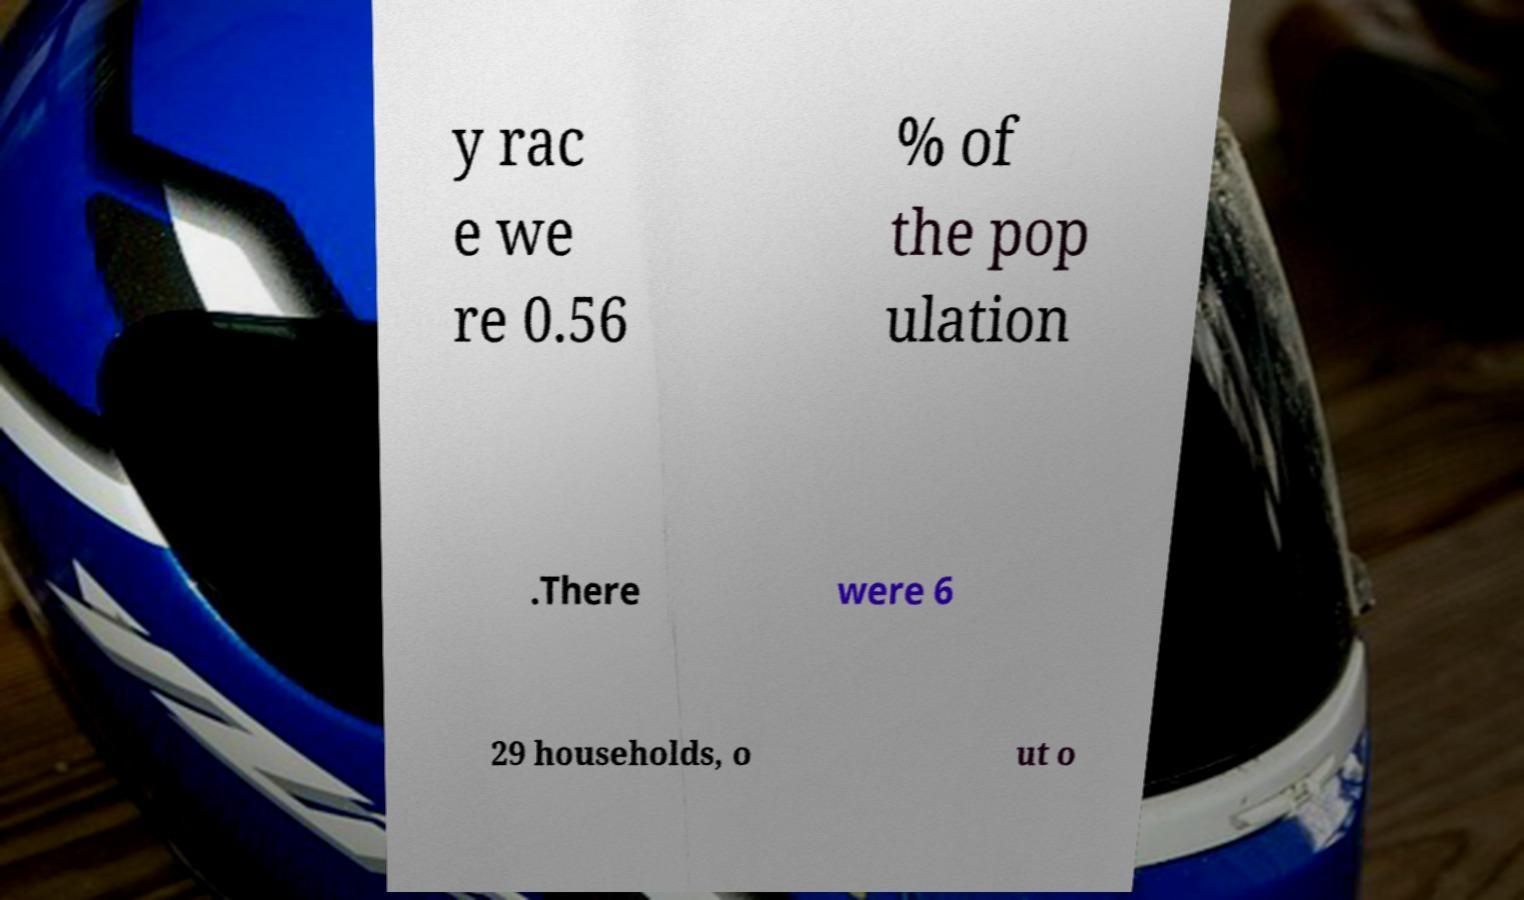For documentation purposes, I need the text within this image transcribed. Could you provide that? y rac e we re 0.56 % of the pop ulation .There were 6 29 households, o ut o 